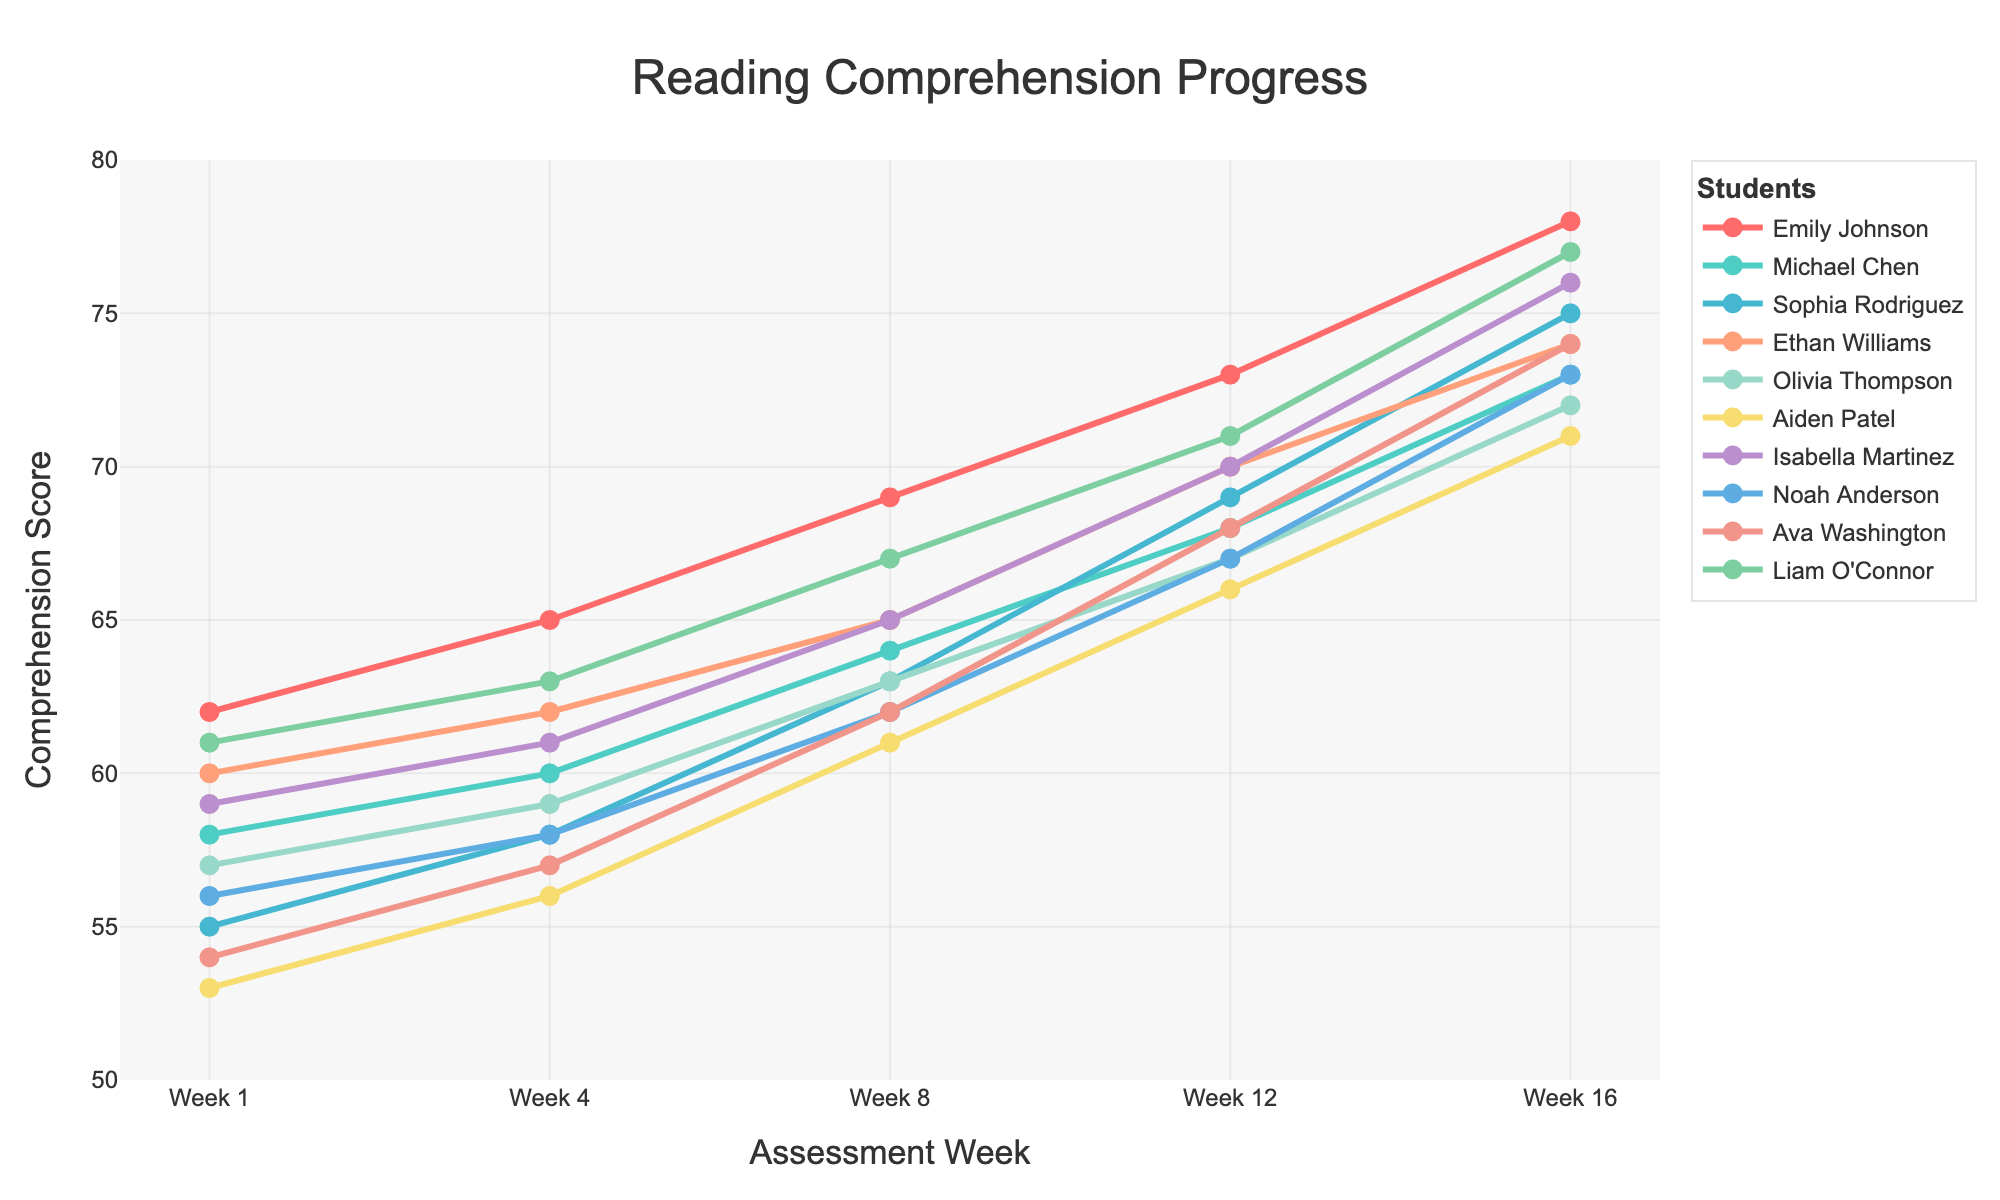What is the general trend of reading comprehension scores over the semester for struggling readers? By observing the line chart, we can see that the scores for all students generally increase from Week 1 to Week 16. This indicates an upward trend in reading comprehension scores over the semester.
Answer: Upward trend Which student showed the highest improvement in reading comprehension scores by Week 16 compared to Week 1? We need to calculate the difference between Week 16 and Week 1 scores for each student. The differences are: Emily Johnson (16), Michael Chen (15), Sophia Rodriguez (20), Ethan Williams (14), Olivia Thompson (15), Aiden Patel (18), Isabella Martinez (17), Noah Anderson (17), Ava Washington (20), and Liam O'Connor (16). Both Sophia Rodriguez and Ava Washington showed the highest improvement with an increase of 20 points.
Answer: Sophia Rodriguez and Ava Washington How did Ethan Williams' scores compare with Olivia Thompson's across the weeks? For each assessment week, we compare Ethan's score with Olivia's score:
Week 1: Ethan (60) > Olivia (57)
Week 4: Ethan (62) > Olivia (59)
Week 8: Ethan (65) = Olivia (63)
Week 12: Ethan (70) > Olivia (67)
Week 16: Ethan (74) > Olivia (72) 
Overall, Ethan's scores were higher than Olivia's in all the weeks except Week 8, where they were equal.
Answer: Ethan's scores were mostly higher How many students had a final comprehension score greater than 75 in Week 16? Referring to Week 16, we see the scores are: Emily Johnson (78), Michael Chen (73), Sophia Rodriguez (75), Ethan Williams (74), Olivia Thompson (72), Aiden Patel (71), Isabella Martinez (76), Noah Anderson (73), Ava Washington (74), Liam O'Connor (77). Students with scores greater than 75 are Emily Johnson, Isabella Martinez, and Liam O'Connor.
Answer: 3 students Which student had the least improvement over the semester? By calculating the differences between Week 16 and Week 1 scores: Emily Johnson (16), Michael Chen (15), Sophia Rodriguez (20), Ethan Williams (14), Olivia Thompson (15), Aiden Patel (18), Isabella Martinez (17), Noah Anderson (17), Ava Washington (20), Liam O'Connor (16). The smallest improvement is seen in Ethan Williams with an increase of 14 points.
Answer: Ethan Williams At which week did Olivia Thompson's scores equal or surpass 65? We examine Olivia's scores across the weeks: Week 1 (57), Week 4 (59), Week 8 (63), Week 12 (67), Week 16 (72). Olivia's score surpassed 65 in Week 12 and that week onwards.
Answer: Week 12 Who had the highest score in Week 8, and what was the score? Looking at Week 8 scores: Emily Johnson (69), Michael Chen (64), Sophia Rodriguez (63), Ethan Williams (65), Olivia Thompson (63), Aiden Patel (61), Isabella Martinez (65), Noah Anderson (62), Ava Washington (62), Liam O'Connor (67). The highest score in Week 8 is 69 by Emily Johnson.
Answer: Emily Johnson with 69 Do any students' scores decrease in any week interval? If so, which students and in which weeks? We need to check if any students have a lower score in a later week compared to an earlier week:
- From Week 1 to Week 4: No decrease.
- From Week 4 to Week 8: No decrease.
- From Week 8 to Week 12: No decrease.
- From Week 12 to Week 16: No decrease.
Thus, no students’ scores decrease in any week interval; all are either constant or increasing.
Answer: No students What is the median score of all students in Week 16? The scores in Week 16 are: 78, 73, 75, 74, 72, 71, 76, 73, 74, 77. Ordering them: 71, 72, 73, 73, 74, 74, 75, 76, 77, 78, the median is the average of the 5th and 6th values: (74+74)/2 = 74.
Answer: 74 Which student had a score closest to the group's average score in Week 1? The Week 1 scores are: 62, 58, 55, 60, 57, 53, 59, 56, 54, 61. The average score is (62+58+55+60+57+53+59+56+54+61)/10 = 57.5. The closest scores to 57.5 are Olivia Thompson (57) and Noah Anderson (56), with Olivia Thompson being slightly closer.
Answer: Olivia Thompson 